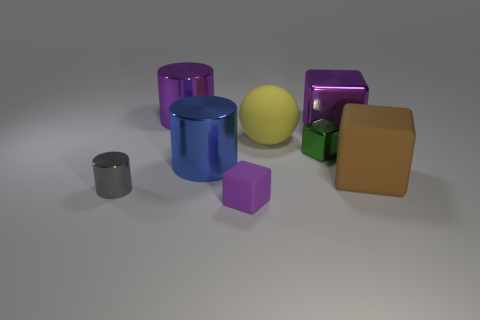Add 1 small rubber blocks. How many objects exist? 9 Subtract all balls. How many objects are left? 7 Add 1 large rubber blocks. How many large rubber blocks are left? 2 Add 5 yellow objects. How many yellow objects exist? 6 Subtract 0 blue blocks. How many objects are left? 8 Subtract all large cyan blocks. Subtract all large yellow spheres. How many objects are left? 7 